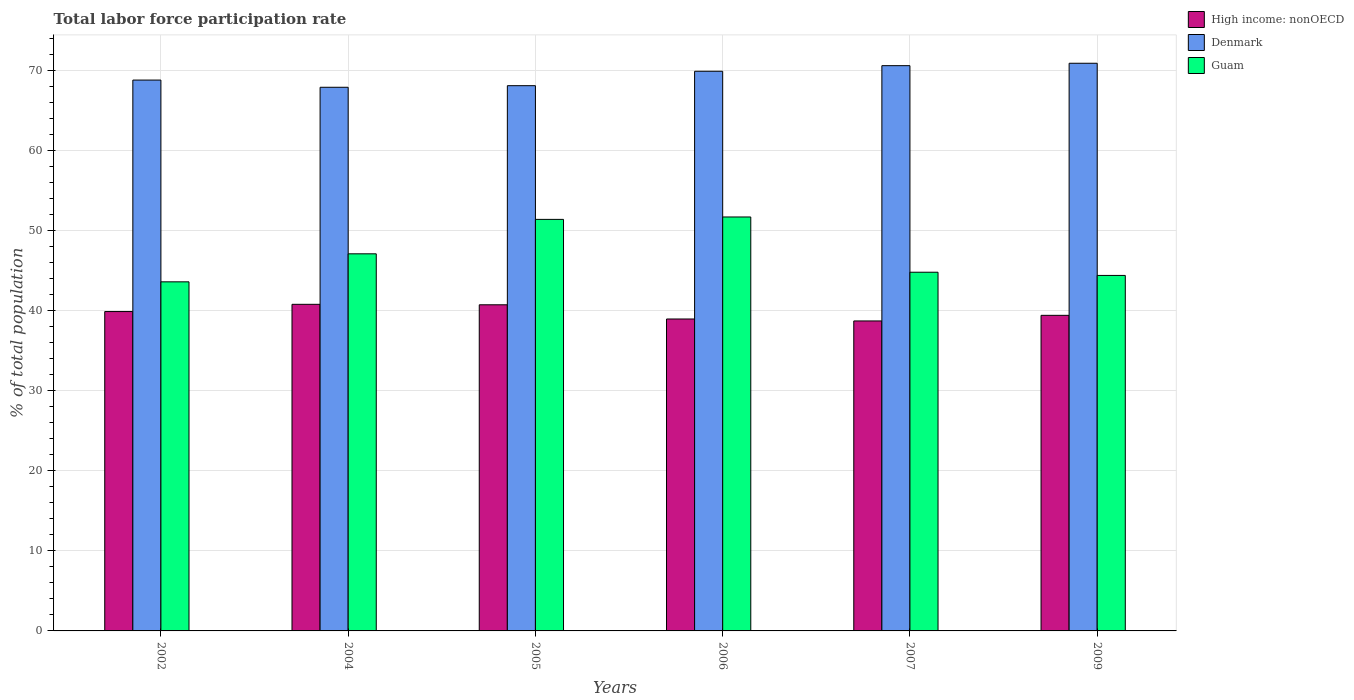How many different coloured bars are there?
Provide a succinct answer. 3. Are the number of bars on each tick of the X-axis equal?
Keep it short and to the point. Yes. What is the label of the 1st group of bars from the left?
Provide a short and direct response. 2002. In how many cases, is the number of bars for a given year not equal to the number of legend labels?
Make the answer very short. 0. What is the total labor force participation rate in High income: nonOECD in 2009?
Offer a terse response. 39.42. Across all years, what is the maximum total labor force participation rate in High income: nonOECD?
Provide a short and direct response. 40.79. Across all years, what is the minimum total labor force participation rate in Guam?
Make the answer very short. 43.6. What is the total total labor force participation rate in Guam in the graph?
Provide a succinct answer. 283. What is the difference between the total labor force participation rate in Guam in 2005 and that in 2006?
Ensure brevity in your answer.  -0.3. What is the difference between the total labor force participation rate in High income: nonOECD in 2006 and the total labor force participation rate in Guam in 2002?
Your answer should be compact. -4.64. What is the average total labor force participation rate in Guam per year?
Keep it short and to the point. 47.17. In the year 2007, what is the difference between the total labor force participation rate in High income: nonOECD and total labor force participation rate in Guam?
Give a very brief answer. -6.09. What is the ratio of the total labor force participation rate in Denmark in 2002 to that in 2007?
Your response must be concise. 0.97. Is the difference between the total labor force participation rate in High income: nonOECD in 2002 and 2004 greater than the difference between the total labor force participation rate in Guam in 2002 and 2004?
Provide a succinct answer. Yes. What is the difference between the highest and the second highest total labor force participation rate in Guam?
Provide a succinct answer. 0.3. What is the difference between the highest and the lowest total labor force participation rate in Guam?
Make the answer very short. 8.1. Is the sum of the total labor force participation rate in High income: nonOECD in 2002 and 2007 greater than the maximum total labor force participation rate in Denmark across all years?
Offer a terse response. Yes. What does the 1st bar from the left in 2005 represents?
Give a very brief answer. High income: nonOECD. What does the 1st bar from the right in 2002 represents?
Give a very brief answer. Guam. Are the values on the major ticks of Y-axis written in scientific E-notation?
Make the answer very short. No. Does the graph contain any zero values?
Provide a succinct answer. No. How many legend labels are there?
Make the answer very short. 3. How are the legend labels stacked?
Your answer should be very brief. Vertical. What is the title of the graph?
Keep it short and to the point. Total labor force participation rate. What is the label or title of the Y-axis?
Your response must be concise. % of total population. What is the % of total population in High income: nonOECD in 2002?
Ensure brevity in your answer.  39.89. What is the % of total population in Denmark in 2002?
Keep it short and to the point. 68.8. What is the % of total population of Guam in 2002?
Ensure brevity in your answer.  43.6. What is the % of total population in High income: nonOECD in 2004?
Provide a succinct answer. 40.79. What is the % of total population in Denmark in 2004?
Keep it short and to the point. 67.9. What is the % of total population of Guam in 2004?
Your answer should be compact. 47.1. What is the % of total population of High income: nonOECD in 2005?
Make the answer very short. 40.73. What is the % of total population in Denmark in 2005?
Provide a succinct answer. 68.1. What is the % of total population of Guam in 2005?
Your response must be concise. 51.4. What is the % of total population in High income: nonOECD in 2006?
Your response must be concise. 38.96. What is the % of total population in Denmark in 2006?
Keep it short and to the point. 69.9. What is the % of total population of Guam in 2006?
Your answer should be very brief. 51.7. What is the % of total population of High income: nonOECD in 2007?
Make the answer very short. 38.71. What is the % of total population in Denmark in 2007?
Offer a terse response. 70.6. What is the % of total population in Guam in 2007?
Provide a succinct answer. 44.8. What is the % of total population of High income: nonOECD in 2009?
Make the answer very short. 39.42. What is the % of total population in Denmark in 2009?
Give a very brief answer. 70.9. What is the % of total population in Guam in 2009?
Provide a short and direct response. 44.4. Across all years, what is the maximum % of total population of High income: nonOECD?
Ensure brevity in your answer.  40.79. Across all years, what is the maximum % of total population in Denmark?
Offer a very short reply. 70.9. Across all years, what is the maximum % of total population of Guam?
Your answer should be compact. 51.7. Across all years, what is the minimum % of total population of High income: nonOECD?
Provide a short and direct response. 38.71. Across all years, what is the minimum % of total population of Denmark?
Provide a short and direct response. 67.9. Across all years, what is the minimum % of total population of Guam?
Provide a short and direct response. 43.6. What is the total % of total population in High income: nonOECD in the graph?
Your answer should be compact. 238.5. What is the total % of total population of Denmark in the graph?
Keep it short and to the point. 416.2. What is the total % of total population in Guam in the graph?
Ensure brevity in your answer.  283. What is the difference between the % of total population of High income: nonOECD in 2002 and that in 2004?
Make the answer very short. -0.9. What is the difference between the % of total population of High income: nonOECD in 2002 and that in 2005?
Make the answer very short. -0.84. What is the difference between the % of total population in Denmark in 2002 and that in 2005?
Provide a short and direct response. 0.7. What is the difference between the % of total population in High income: nonOECD in 2002 and that in 2006?
Offer a very short reply. 0.93. What is the difference between the % of total population of High income: nonOECD in 2002 and that in 2007?
Offer a very short reply. 1.17. What is the difference between the % of total population of Denmark in 2002 and that in 2007?
Offer a terse response. -1.8. What is the difference between the % of total population of High income: nonOECD in 2002 and that in 2009?
Provide a short and direct response. 0.47. What is the difference between the % of total population of Denmark in 2002 and that in 2009?
Make the answer very short. -2.1. What is the difference between the % of total population of Guam in 2002 and that in 2009?
Your response must be concise. -0.8. What is the difference between the % of total population in High income: nonOECD in 2004 and that in 2005?
Make the answer very short. 0.06. What is the difference between the % of total population in Denmark in 2004 and that in 2005?
Offer a terse response. -0.2. What is the difference between the % of total population of High income: nonOECD in 2004 and that in 2006?
Offer a terse response. 1.83. What is the difference between the % of total population of High income: nonOECD in 2004 and that in 2007?
Give a very brief answer. 2.08. What is the difference between the % of total population of Guam in 2004 and that in 2007?
Provide a succinct answer. 2.3. What is the difference between the % of total population of High income: nonOECD in 2004 and that in 2009?
Provide a short and direct response. 1.38. What is the difference between the % of total population in Denmark in 2004 and that in 2009?
Provide a succinct answer. -3. What is the difference between the % of total population in Guam in 2004 and that in 2009?
Offer a very short reply. 2.7. What is the difference between the % of total population in High income: nonOECD in 2005 and that in 2006?
Ensure brevity in your answer.  1.77. What is the difference between the % of total population of Denmark in 2005 and that in 2006?
Your answer should be compact. -1.8. What is the difference between the % of total population of High income: nonOECD in 2005 and that in 2007?
Offer a terse response. 2.02. What is the difference between the % of total population of Guam in 2005 and that in 2007?
Your answer should be very brief. 6.6. What is the difference between the % of total population of High income: nonOECD in 2005 and that in 2009?
Provide a succinct answer. 1.32. What is the difference between the % of total population in High income: nonOECD in 2006 and that in 2007?
Your answer should be very brief. 0.25. What is the difference between the % of total population of Denmark in 2006 and that in 2007?
Your answer should be very brief. -0.7. What is the difference between the % of total population in Guam in 2006 and that in 2007?
Provide a succinct answer. 6.9. What is the difference between the % of total population of High income: nonOECD in 2006 and that in 2009?
Offer a terse response. -0.46. What is the difference between the % of total population in Guam in 2006 and that in 2009?
Your response must be concise. 7.3. What is the difference between the % of total population of High income: nonOECD in 2007 and that in 2009?
Keep it short and to the point. -0.7. What is the difference between the % of total population of Denmark in 2007 and that in 2009?
Your answer should be compact. -0.3. What is the difference between the % of total population in High income: nonOECD in 2002 and the % of total population in Denmark in 2004?
Offer a very short reply. -28.01. What is the difference between the % of total population in High income: nonOECD in 2002 and the % of total population in Guam in 2004?
Provide a succinct answer. -7.21. What is the difference between the % of total population of Denmark in 2002 and the % of total population of Guam in 2004?
Keep it short and to the point. 21.7. What is the difference between the % of total population of High income: nonOECD in 2002 and the % of total population of Denmark in 2005?
Make the answer very short. -28.21. What is the difference between the % of total population in High income: nonOECD in 2002 and the % of total population in Guam in 2005?
Provide a short and direct response. -11.51. What is the difference between the % of total population of Denmark in 2002 and the % of total population of Guam in 2005?
Keep it short and to the point. 17.4. What is the difference between the % of total population in High income: nonOECD in 2002 and the % of total population in Denmark in 2006?
Make the answer very short. -30.01. What is the difference between the % of total population of High income: nonOECD in 2002 and the % of total population of Guam in 2006?
Give a very brief answer. -11.81. What is the difference between the % of total population of Denmark in 2002 and the % of total population of Guam in 2006?
Ensure brevity in your answer.  17.1. What is the difference between the % of total population in High income: nonOECD in 2002 and the % of total population in Denmark in 2007?
Keep it short and to the point. -30.71. What is the difference between the % of total population in High income: nonOECD in 2002 and the % of total population in Guam in 2007?
Your answer should be compact. -4.91. What is the difference between the % of total population of High income: nonOECD in 2002 and the % of total population of Denmark in 2009?
Provide a short and direct response. -31.01. What is the difference between the % of total population of High income: nonOECD in 2002 and the % of total population of Guam in 2009?
Give a very brief answer. -4.51. What is the difference between the % of total population in Denmark in 2002 and the % of total population in Guam in 2009?
Give a very brief answer. 24.4. What is the difference between the % of total population in High income: nonOECD in 2004 and the % of total population in Denmark in 2005?
Your answer should be very brief. -27.31. What is the difference between the % of total population of High income: nonOECD in 2004 and the % of total population of Guam in 2005?
Your response must be concise. -10.61. What is the difference between the % of total population of High income: nonOECD in 2004 and the % of total population of Denmark in 2006?
Offer a terse response. -29.11. What is the difference between the % of total population of High income: nonOECD in 2004 and the % of total population of Guam in 2006?
Ensure brevity in your answer.  -10.91. What is the difference between the % of total population in Denmark in 2004 and the % of total population in Guam in 2006?
Make the answer very short. 16.2. What is the difference between the % of total population of High income: nonOECD in 2004 and the % of total population of Denmark in 2007?
Keep it short and to the point. -29.81. What is the difference between the % of total population of High income: nonOECD in 2004 and the % of total population of Guam in 2007?
Give a very brief answer. -4.01. What is the difference between the % of total population in Denmark in 2004 and the % of total population in Guam in 2007?
Ensure brevity in your answer.  23.1. What is the difference between the % of total population in High income: nonOECD in 2004 and the % of total population in Denmark in 2009?
Offer a very short reply. -30.11. What is the difference between the % of total population in High income: nonOECD in 2004 and the % of total population in Guam in 2009?
Keep it short and to the point. -3.61. What is the difference between the % of total population in High income: nonOECD in 2005 and the % of total population in Denmark in 2006?
Ensure brevity in your answer.  -29.17. What is the difference between the % of total population of High income: nonOECD in 2005 and the % of total population of Guam in 2006?
Give a very brief answer. -10.97. What is the difference between the % of total population of High income: nonOECD in 2005 and the % of total population of Denmark in 2007?
Offer a terse response. -29.87. What is the difference between the % of total population in High income: nonOECD in 2005 and the % of total population in Guam in 2007?
Ensure brevity in your answer.  -4.07. What is the difference between the % of total population of Denmark in 2005 and the % of total population of Guam in 2007?
Your response must be concise. 23.3. What is the difference between the % of total population in High income: nonOECD in 2005 and the % of total population in Denmark in 2009?
Your answer should be compact. -30.17. What is the difference between the % of total population in High income: nonOECD in 2005 and the % of total population in Guam in 2009?
Your answer should be very brief. -3.67. What is the difference between the % of total population in Denmark in 2005 and the % of total population in Guam in 2009?
Provide a succinct answer. 23.7. What is the difference between the % of total population in High income: nonOECD in 2006 and the % of total population in Denmark in 2007?
Keep it short and to the point. -31.64. What is the difference between the % of total population of High income: nonOECD in 2006 and the % of total population of Guam in 2007?
Provide a succinct answer. -5.84. What is the difference between the % of total population of Denmark in 2006 and the % of total population of Guam in 2007?
Your answer should be compact. 25.1. What is the difference between the % of total population in High income: nonOECD in 2006 and the % of total population in Denmark in 2009?
Offer a terse response. -31.94. What is the difference between the % of total population of High income: nonOECD in 2006 and the % of total population of Guam in 2009?
Offer a terse response. -5.44. What is the difference between the % of total population in Denmark in 2006 and the % of total population in Guam in 2009?
Offer a terse response. 25.5. What is the difference between the % of total population of High income: nonOECD in 2007 and the % of total population of Denmark in 2009?
Offer a very short reply. -32.19. What is the difference between the % of total population of High income: nonOECD in 2007 and the % of total population of Guam in 2009?
Make the answer very short. -5.69. What is the difference between the % of total population in Denmark in 2007 and the % of total population in Guam in 2009?
Make the answer very short. 26.2. What is the average % of total population of High income: nonOECD per year?
Provide a succinct answer. 39.75. What is the average % of total population of Denmark per year?
Offer a very short reply. 69.37. What is the average % of total population of Guam per year?
Offer a terse response. 47.17. In the year 2002, what is the difference between the % of total population in High income: nonOECD and % of total population in Denmark?
Keep it short and to the point. -28.91. In the year 2002, what is the difference between the % of total population of High income: nonOECD and % of total population of Guam?
Offer a terse response. -3.71. In the year 2002, what is the difference between the % of total population in Denmark and % of total population in Guam?
Offer a terse response. 25.2. In the year 2004, what is the difference between the % of total population of High income: nonOECD and % of total population of Denmark?
Ensure brevity in your answer.  -27.11. In the year 2004, what is the difference between the % of total population in High income: nonOECD and % of total population in Guam?
Provide a short and direct response. -6.31. In the year 2004, what is the difference between the % of total population in Denmark and % of total population in Guam?
Provide a short and direct response. 20.8. In the year 2005, what is the difference between the % of total population of High income: nonOECD and % of total population of Denmark?
Make the answer very short. -27.37. In the year 2005, what is the difference between the % of total population in High income: nonOECD and % of total population in Guam?
Ensure brevity in your answer.  -10.67. In the year 2005, what is the difference between the % of total population in Denmark and % of total population in Guam?
Offer a very short reply. 16.7. In the year 2006, what is the difference between the % of total population in High income: nonOECD and % of total population in Denmark?
Your answer should be compact. -30.94. In the year 2006, what is the difference between the % of total population in High income: nonOECD and % of total population in Guam?
Your answer should be compact. -12.74. In the year 2007, what is the difference between the % of total population in High income: nonOECD and % of total population in Denmark?
Make the answer very short. -31.89. In the year 2007, what is the difference between the % of total population of High income: nonOECD and % of total population of Guam?
Give a very brief answer. -6.09. In the year 2007, what is the difference between the % of total population of Denmark and % of total population of Guam?
Your response must be concise. 25.8. In the year 2009, what is the difference between the % of total population in High income: nonOECD and % of total population in Denmark?
Your response must be concise. -31.48. In the year 2009, what is the difference between the % of total population of High income: nonOECD and % of total population of Guam?
Your response must be concise. -4.98. What is the ratio of the % of total population of High income: nonOECD in 2002 to that in 2004?
Ensure brevity in your answer.  0.98. What is the ratio of the % of total population in Denmark in 2002 to that in 2004?
Offer a very short reply. 1.01. What is the ratio of the % of total population in Guam in 2002 to that in 2004?
Make the answer very short. 0.93. What is the ratio of the % of total population of High income: nonOECD in 2002 to that in 2005?
Offer a very short reply. 0.98. What is the ratio of the % of total population in Denmark in 2002 to that in 2005?
Your answer should be compact. 1.01. What is the ratio of the % of total population of Guam in 2002 to that in 2005?
Your answer should be compact. 0.85. What is the ratio of the % of total population of High income: nonOECD in 2002 to that in 2006?
Keep it short and to the point. 1.02. What is the ratio of the % of total population of Denmark in 2002 to that in 2006?
Make the answer very short. 0.98. What is the ratio of the % of total population in Guam in 2002 to that in 2006?
Offer a terse response. 0.84. What is the ratio of the % of total population in High income: nonOECD in 2002 to that in 2007?
Offer a terse response. 1.03. What is the ratio of the % of total population in Denmark in 2002 to that in 2007?
Keep it short and to the point. 0.97. What is the ratio of the % of total population of Guam in 2002 to that in 2007?
Offer a very short reply. 0.97. What is the ratio of the % of total population of Denmark in 2002 to that in 2009?
Give a very brief answer. 0.97. What is the ratio of the % of total population of Guam in 2004 to that in 2005?
Provide a short and direct response. 0.92. What is the ratio of the % of total population of High income: nonOECD in 2004 to that in 2006?
Provide a short and direct response. 1.05. What is the ratio of the % of total population in Denmark in 2004 to that in 2006?
Your response must be concise. 0.97. What is the ratio of the % of total population of Guam in 2004 to that in 2006?
Keep it short and to the point. 0.91. What is the ratio of the % of total population of High income: nonOECD in 2004 to that in 2007?
Make the answer very short. 1.05. What is the ratio of the % of total population in Denmark in 2004 to that in 2007?
Your response must be concise. 0.96. What is the ratio of the % of total population of Guam in 2004 to that in 2007?
Make the answer very short. 1.05. What is the ratio of the % of total population of High income: nonOECD in 2004 to that in 2009?
Make the answer very short. 1.03. What is the ratio of the % of total population of Denmark in 2004 to that in 2009?
Provide a short and direct response. 0.96. What is the ratio of the % of total population in Guam in 2004 to that in 2009?
Make the answer very short. 1.06. What is the ratio of the % of total population in High income: nonOECD in 2005 to that in 2006?
Provide a succinct answer. 1.05. What is the ratio of the % of total population of Denmark in 2005 to that in 2006?
Provide a short and direct response. 0.97. What is the ratio of the % of total population of Guam in 2005 to that in 2006?
Your answer should be very brief. 0.99. What is the ratio of the % of total population of High income: nonOECD in 2005 to that in 2007?
Ensure brevity in your answer.  1.05. What is the ratio of the % of total population of Denmark in 2005 to that in 2007?
Your answer should be very brief. 0.96. What is the ratio of the % of total population in Guam in 2005 to that in 2007?
Keep it short and to the point. 1.15. What is the ratio of the % of total population in High income: nonOECD in 2005 to that in 2009?
Provide a succinct answer. 1.03. What is the ratio of the % of total population in Denmark in 2005 to that in 2009?
Offer a terse response. 0.96. What is the ratio of the % of total population of Guam in 2005 to that in 2009?
Your answer should be compact. 1.16. What is the ratio of the % of total population in High income: nonOECD in 2006 to that in 2007?
Provide a short and direct response. 1.01. What is the ratio of the % of total population in Guam in 2006 to that in 2007?
Ensure brevity in your answer.  1.15. What is the ratio of the % of total population in High income: nonOECD in 2006 to that in 2009?
Give a very brief answer. 0.99. What is the ratio of the % of total population of Denmark in 2006 to that in 2009?
Your answer should be compact. 0.99. What is the ratio of the % of total population in Guam in 2006 to that in 2009?
Your answer should be compact. 1.16. What is the ratio of the % of total population of High income: nonOECD in 2007 to that in 2009?
Your answer should be compact. 0.98. What is the difference between the highest and the second highest % of total population in High income: nonOECD?
Give a very brief answer. 0.06. What is the difference between the highest and the second highest % of total population in Denmark?
Your answer should be very brief. 0.3. What is the difference between the highest and the second highest % of total population in Guam?
Offer a terse response. 0.3. What is the difference between the highest and the lowest % of total population of High income: nonOECD?
Make the answer very short. 2.08. What is the difference between the highest and the lowest % of total population of Denmark?
Provide a succinct answer. 3. What is the difference between the highest and the lowest % of total population in Guam?
Your response must be concise. 8.1. 